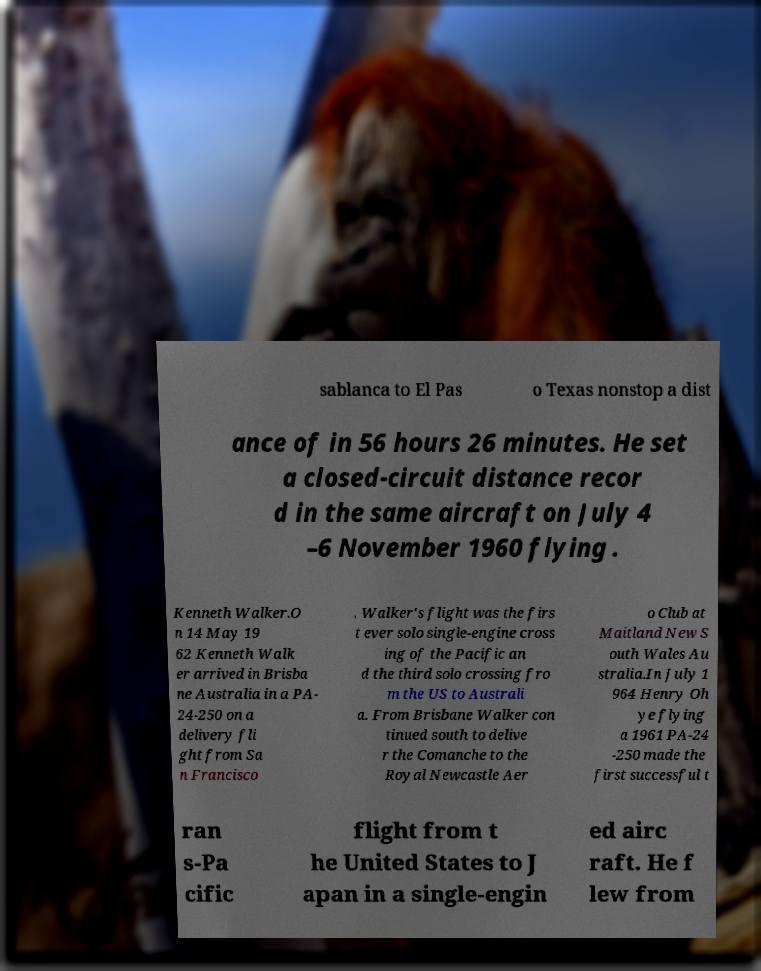Please identify and transcribe the text found in this image. sablanca to El Pas o Texas nonstop a dist ance of in 56 hours 26 minutes. He set a closed-circuit distance recor d in the same aircraft on July 4 –6 November 1960 flying . Kenneth Walker.O n 14 May 19 62 Kenneth Walk er arrived in Brisba ne Australia in a PA- 24-250 on a delivery fli ght from Sa n Francisco . Walker's flight was the firs t ever solo single-engine cross ing of the Pacific an d the third solo crossing fro m the US to Australi a. From Brisbane Walker con tinued south to delive r the Comanche to the Royal Newcastle Aer o Club at Maitland New S outh Wales Au stralia.In July 1 964 Henry Oh ye flying a 1961 PA-24 -250 made the first successful t ran s-Pa cific flight from t he United States to J apan in a single-engin ed airc raft. He f lew from 